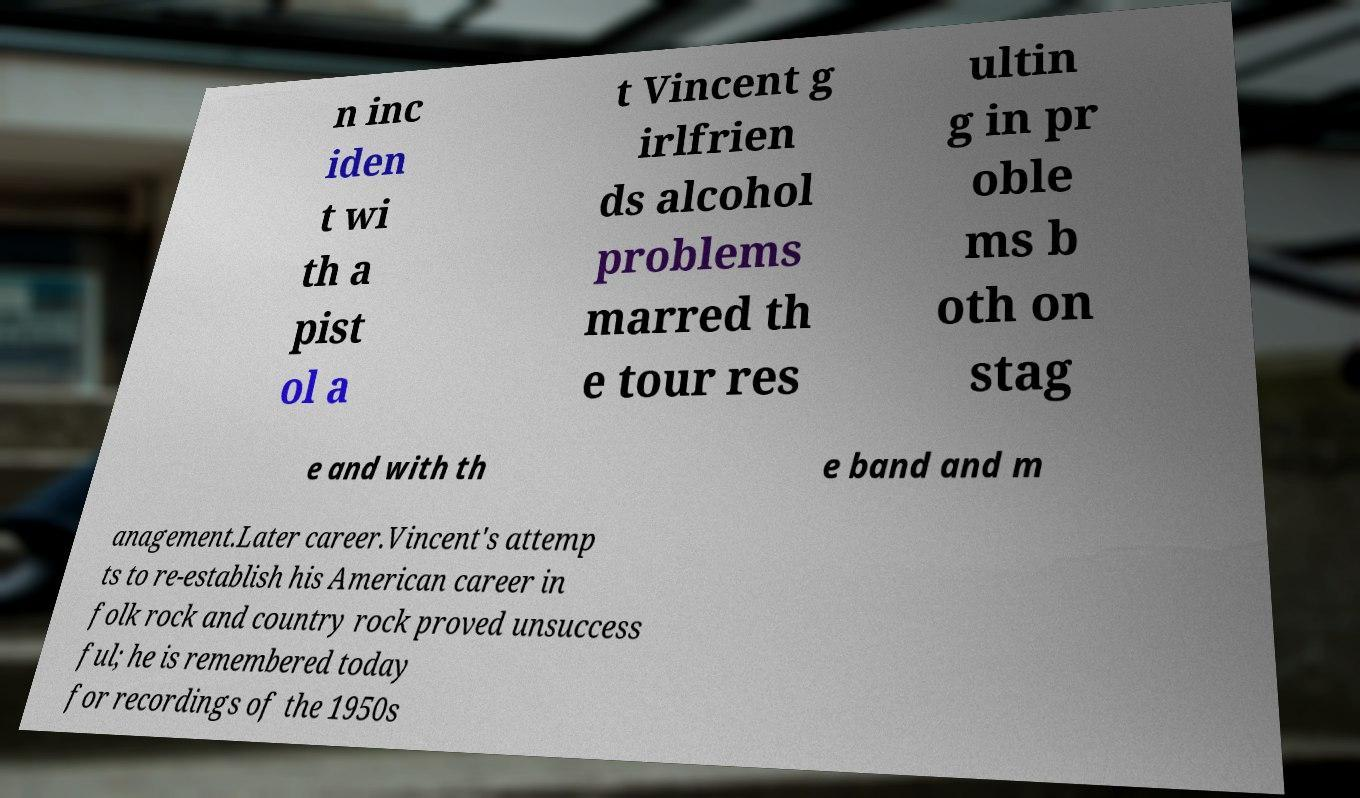Could you extract and type out the text from this image? n inc iden t wi th a pist ol a t Vincent g irlfrien ds alcohol problems marred th e tour res ultin g in pr oble ms b oth on stag e and with th e band and m anagement.Later career.Vincent's attemp ts to re-establish his American career in folk rock and country rock proved unsuccess ful; he is remembered today for recordings of the 1950s 